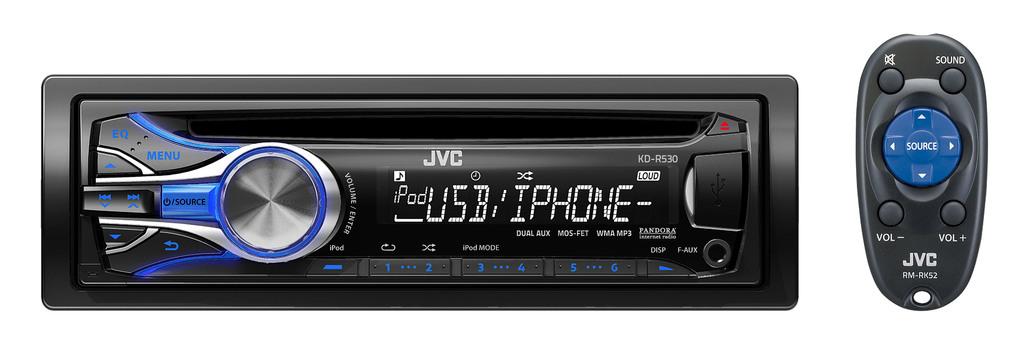What does the blue button in the center of the remote say?
Offer a terse response. Source. 